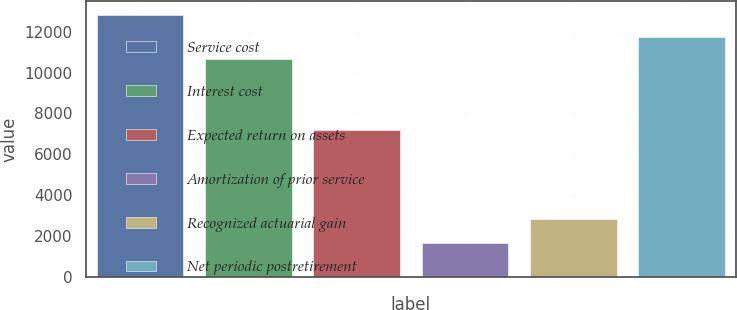<chart> <loc_0><loc_0><loc_500><loc_500><bar_chart><fcel>Service cost<fcel>Interest cost<fcel>Expected return on assets<fcel>Amortization of prior service<fcel>Recognized actuarial gain<fcel>Net periodic postretirement<nl><fcel>12837.4<fcel>10679<fcel>7185<fcel>1644<fcel>2827<fcel>11758.2<nl></chart> 